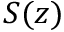<formula> <loc_0><loc_0><loc_500><loc_500>S ( z )</formula> 